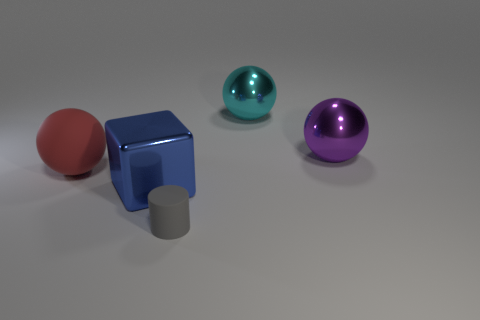Subtract all big red balls. How many balls are left? 2 Add 3 big cyan metal spheres. How many objects exist? 8 Subtract all red spheres. How many spheres are left? 2 Subtract all blocks. How many objects are left? 4 Subtract 1 balls. How many balls are left? 2 Subtract all green cylinders. Subtract all blue spheres. How many cylinders are left? 1 Add 3 small brown metal things. How many small brown metal things exist? 3 Subtract 0 yellow balls. How many objects are left? 5 Subtract all gray cylinders. How many purple balls are left? 1 Subtract all purple matte objects. Subtract all large red things. How many objects are left? 4 